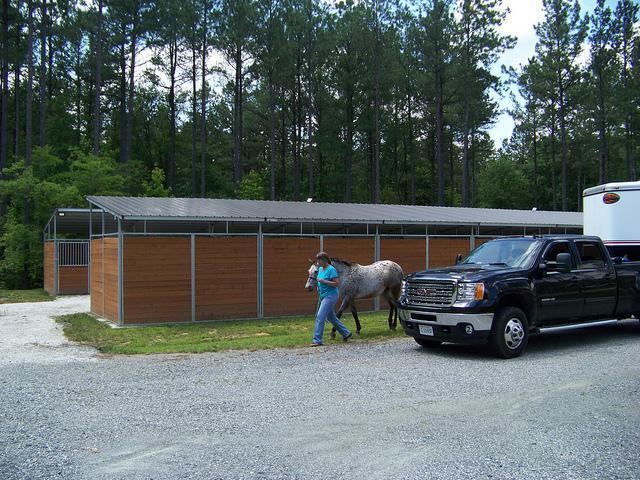How many animals?
Give a very brief answer. 1. 